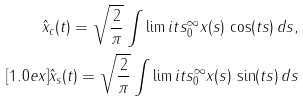<formula> <loc_0><loc_0><loc_500><loc_500>\hat { x } _ { c } ( t ) = \sqrt { \frac { 2 } { \pi } } \int \lim i t s _ { 0 } ^ { \infty } x ( s ) \, \cos ( t s ) \, d s , \\ [ 1 . 0 e x ] \hat { x } _ { s } ( t ) = \sqrt { \frac { 2 } { \pi } } \int \lim i t s _ { 0 } ^ { \infty } x ( s ) \, \sin ( t s ) \, d s</formula> 